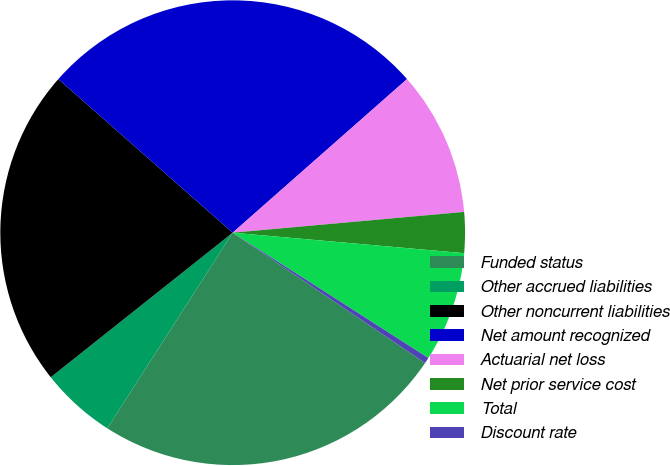Convert chart to OTSL. <chart><loc_0><loc_0><loc_500><loc_500><pie_chart><fcel>Funded status<fcel>Other accrued liabilities<fcel>Other noncurrent liabilities<fcel>Net amount recognized<fcel>Actuarial net loss<fcel>Net prior service cost<fcel>Total<fcel>Discount rate<nl><fcel>24.6%<fcel>5.24%<fcel>22.18%<fcel>27.01%<fcel>10.07%<fcel>2.83%<fcel>7.66%<fcel>0.41%<nl></chart> 